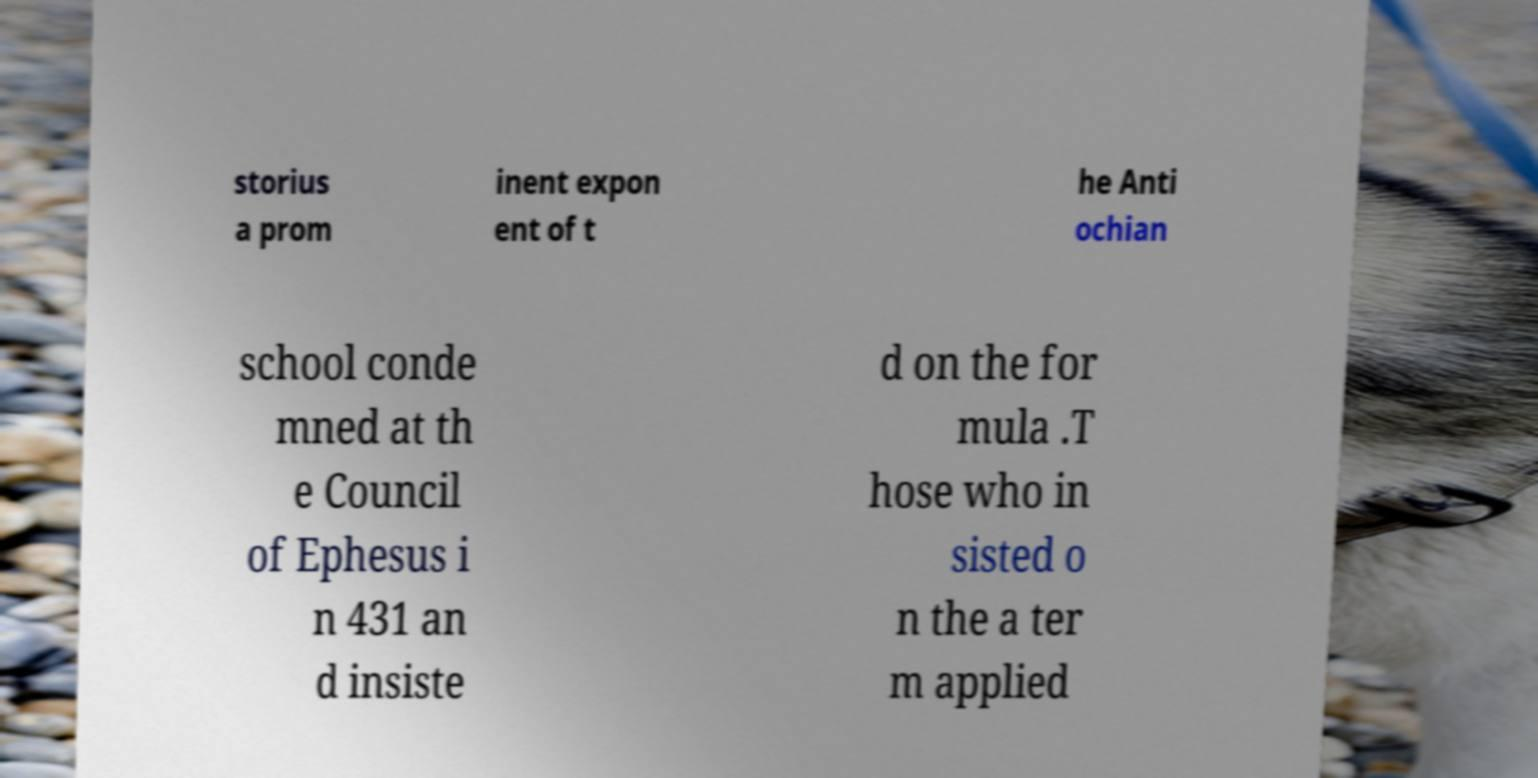Could you extract and type out the text from this image? storius a prom inent expon ent of t he Anti ochian school conde mned at th e Council of Ephesus i n 431 an d insiste d on the for mula .T hose who in sisted o n the a ter m applied 